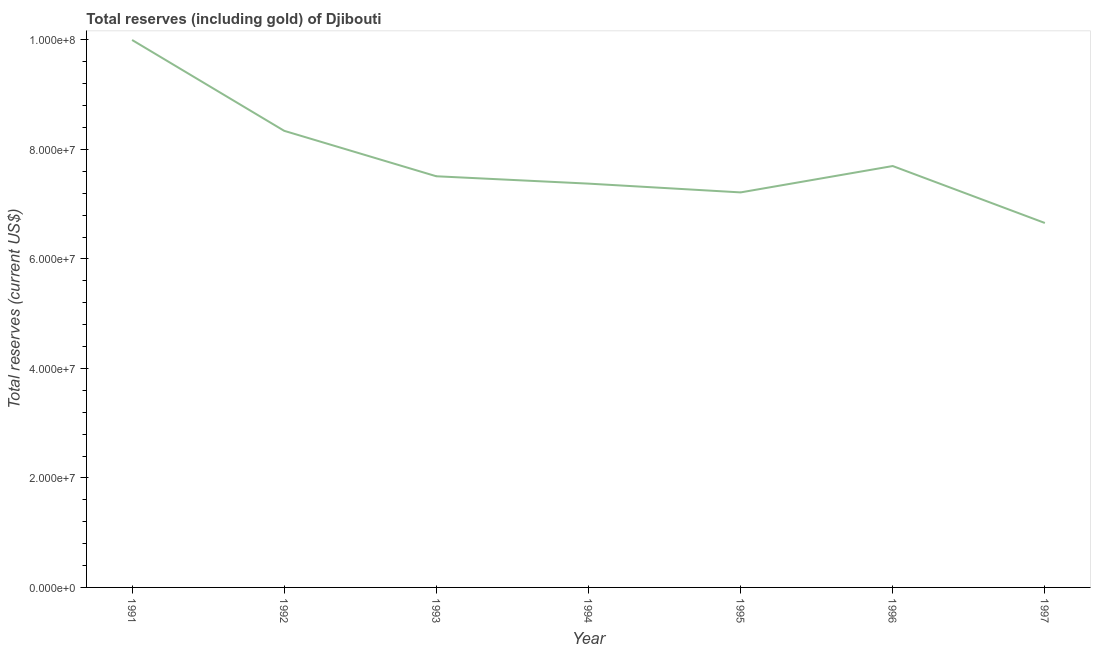What is the total reserves (including gold) in 1996?
Keep it short and to the point. 7.70e+07. Across all years, what is the maximum total reserves (including gold)?
Your answer should be compact. 1.00e+08. Across all years, what is the minimum total reserves (including gold)?
Ensure brevity in your answer.  6.66e+07. In which year was the total reserves (including gold) maximum?
Provide a short and direct response. 1991. In which year was the total reserves (including gold) minimum?
Your response must be concise. 1997. What is the sum of the total reserves (including gold)?
Your response must be concise. 5.48e+08. What is the difference between the total reserves (including gold) in 1993 and 1994?
Your response must be concise. 1.34e+06. What is the average total reserves (including gold) per year?
Ensure brevity in your answer.  7.83e+07. What is the median total reserves (including gold)?
Your answer should be compact. 7.51e+07. In how many years, is the total reserves (including gold) greater than 92000000 US$?
Provide a succinct answer. 1. What is the ratio of the total reserves (including gold) in 1991 to that in 1994?
Your response must be concise. 1.36. Is the total reserves (including gold) in 1993 less than that in 1994?
Your answer should be very brief. No. Is the difference between the total reserves (including gold) in 1991 and 1992 greater than the difference between any two years?
Your answer should be compact. No. What is the difference between the highest and the second highest total reserves (including gold)?
Provide a succinct answer. 1.66e+07. Is the sum of the total reserves (including gold) in 1991 and 1996 greater than the maximum total reserves (including gold) across all years?
Make the answer very short. Yes. What is the difference between the highest and the lowest total reserves (including gold)?
Keep it short and to the point. 3.34e+07. Does the total reserves (including gold) monotonically increase over the years?
Offer a terse response. No. How many years are there in the graph?
Your answer should be compact. 7. Does the graph contain any zero values?
Offer a terse response. No. What is the title of the graph?
Your response must be concise. Total reserves (including gold) of Djibouti. What is the label or title of the X-axis?
Give a very brief answer. Year. What is the label or title of the Y-axis?
Offer a terse response. Total reserves (current US$). What is the Total reserves (current US$) of 1991?
Your answer should be very brief. 1.00e+08. What is the Total reserves (current US$) in 1992?
Provide a succinct answer. 8.34e+07. What is the Total reserves (current US$) of 1993?
Offer a terse response. 7.51e+07. What is the Total reserves (current US$) of 1994?
Make the answer very short. 7.38e+07. What is the Total reserves (current US$) of 1995?
Give a very brief answer. 7.22e+07. What is the Total reserves (current US$) in 1996?
Offer a very short reply. 7.70e+07. What is the Total reserves (current US$) of 1997?
Your response must be concise. 6.66e+07. What is the difference between the Total reserves (current US$) in 1991 and 1992?
Your answer should be very brief. 1.66e+07. What is the difference between the Total reserves (current US$) in 1991 and 1993?
Keep it short and to the point. 2.49e+07. What is the difference between the Total reserves (current US$) in 1991 and 1994?
Provide a short and direct response. 2.62e+07. What is the difference between the Total reserves (current US$) in 1991 and 1995?
Ensure brevity in your answer.  2.78e+07. What is the difference between the Total reserves (current US$) in 1991 and 1996?
Keep it short and to the point. 2.30e+07. What is the difference between the Total reserves (current US$) in 1991 and 1997?
Your answer should be compact. 3.34e+07. What is the difference between the Total reserves (current US$) in 1992 and 1993?
Ensure brevity in your answer.  8.30e+06. What is the difference between the Total reserves (current US$) in 1992 and 1994?
Give a very brief answer. 9.64e+06. What is the difference between the Total reserves (current US$) in 1992 and 1995?
Your answer should be compact. 1.12e+07. What is the difference between the Total reserves (current US$) in 1992 and 1996?
Your answer should be very brief. 6.43e+06. What is the difference between the Total reserves (current US$) in 1992 and 1997?
Offer a very short reply. 1.68e+07. What is the difference between the Total reserves (current US$) in 1993 and 1994?
Make the answer very short. 1.34e+06. What is the difference between the Total reserves (current US$) in 1993 and 1995?
Offer a very short reply. 2.95e+06. What is the difference between the Total reserves (current US$) in 1993 and 1996?
Offer a very short reply. -1.87e+06. What is the difference between the Total reserves (current US$) in 1993 and 1997?
Your response must be concise. 8.53e+06. What is the difference between the Total reserves (current US$) in 1994 and 1995?
Your answer should be compact. 1.60e+06. What is the difference between the Total reserves (current US$) in 1994 and 1996?
Your answer should be very brief. -3.21e+06. What is the difference between the Total reserves (current US$) in 1994 and 1997?
Make the answer very short. 7.19e+06. What is the difference between the Total reserves (current US$) in 1995 and 1996?
Your response must be concise. -4.82e+06. What is the difference between the Total reserves (current US$) in 1995 and 1997?
Provide a succinct answer. 5.59e+06. What is the difference between the Total reserves (current US$) in 1996 and 1997?
Make the answer very short. 1.04e+07. What is the ratio of the Total reserves (current US$) in 1991 to that in 1992?
Offer a very short reply. 1.2. What is the ratio of the Total reserves (current US$) in 1991 to that in 1993?
Provide a succinct answer. 1.33. What is the ratio of the Total reserves (current US$) in 1991 to that in 1994?
Your answer should be compact. 1.36. What is the ratio of the Total reserves (current US$) in 1991 to that in 1995?
Provide a short and direct response. 1.39. What is the ratio of the Total reserves (current US$) in 1991 to that in 1996?
Offer a very short reply. 1.3. What is the ratio of the Total reserves (current US$) in 1991 to that in 1997?
Give a very brief answer. 1.5. What is the ratio of the Total reserves (current US$) in 1992 to that in 1993?
Your answer should be compact. 1.11. What is the ratio of the Total reserves (current US$) in 1992 to that in 1994?
Keep it short and to the point. 1.13. What is the ratio of the Total reserves (current US$) in 1992 to that in 1995?
Keep it short and to the point. 1.16. What is the ratio of the Total reserves (current US$) in 1992 to that in 1996?
Provide a succinct answer. 1.08. What is the ratio of the Total reserves (current US$) in 1992 to that in 1997?
Keep it short and to the point. 1.25. What is the ratio of the Total reserves (current US$) in 1993 to that in 1994?
Your response must be concise. 1.02. What is the ratio of the Total reserves (current US$) in 1993 to that in 1995?
Make the answer very short. 1.04. What is the ratio of the Total reserves (current US$) in 1993 to that in 1996?
Make the answer very short. 0.98. What is the ratio of the Total reserves (current US$) in 1993 to that in 1997?
Give a very brief answer. 1.13. What is the ratio of the Total reserves (current US$) in 1994 to that in 1995?
Provide a short and direct response. 1.02. What is the ratio of the Total reserves (current US$) in 1994 to that in 1996?
Offer a very short reply. 0.96. What is the ratio of the Total reserves (current US$) in 1994 to that in 1997?
Give a very brief answer. 1.11. What is the ratio of the Total reserves (current US$) in 1995 to that in 1996?
Offer a terse response. 0.94. What is the ratio of the Total reserves (current US$) in 1995 to that in 1997?
Offer a terse response. 1.08. What is the ratio of the Total reserves (current US$) in 1996 to that in 1997?
Your answer should be compact. 1.16. 